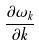<formula> <loc_0><loc_0><loc_500><loc_500>\frac { \partial \omega _ { k } } { \partial k }</formula> 